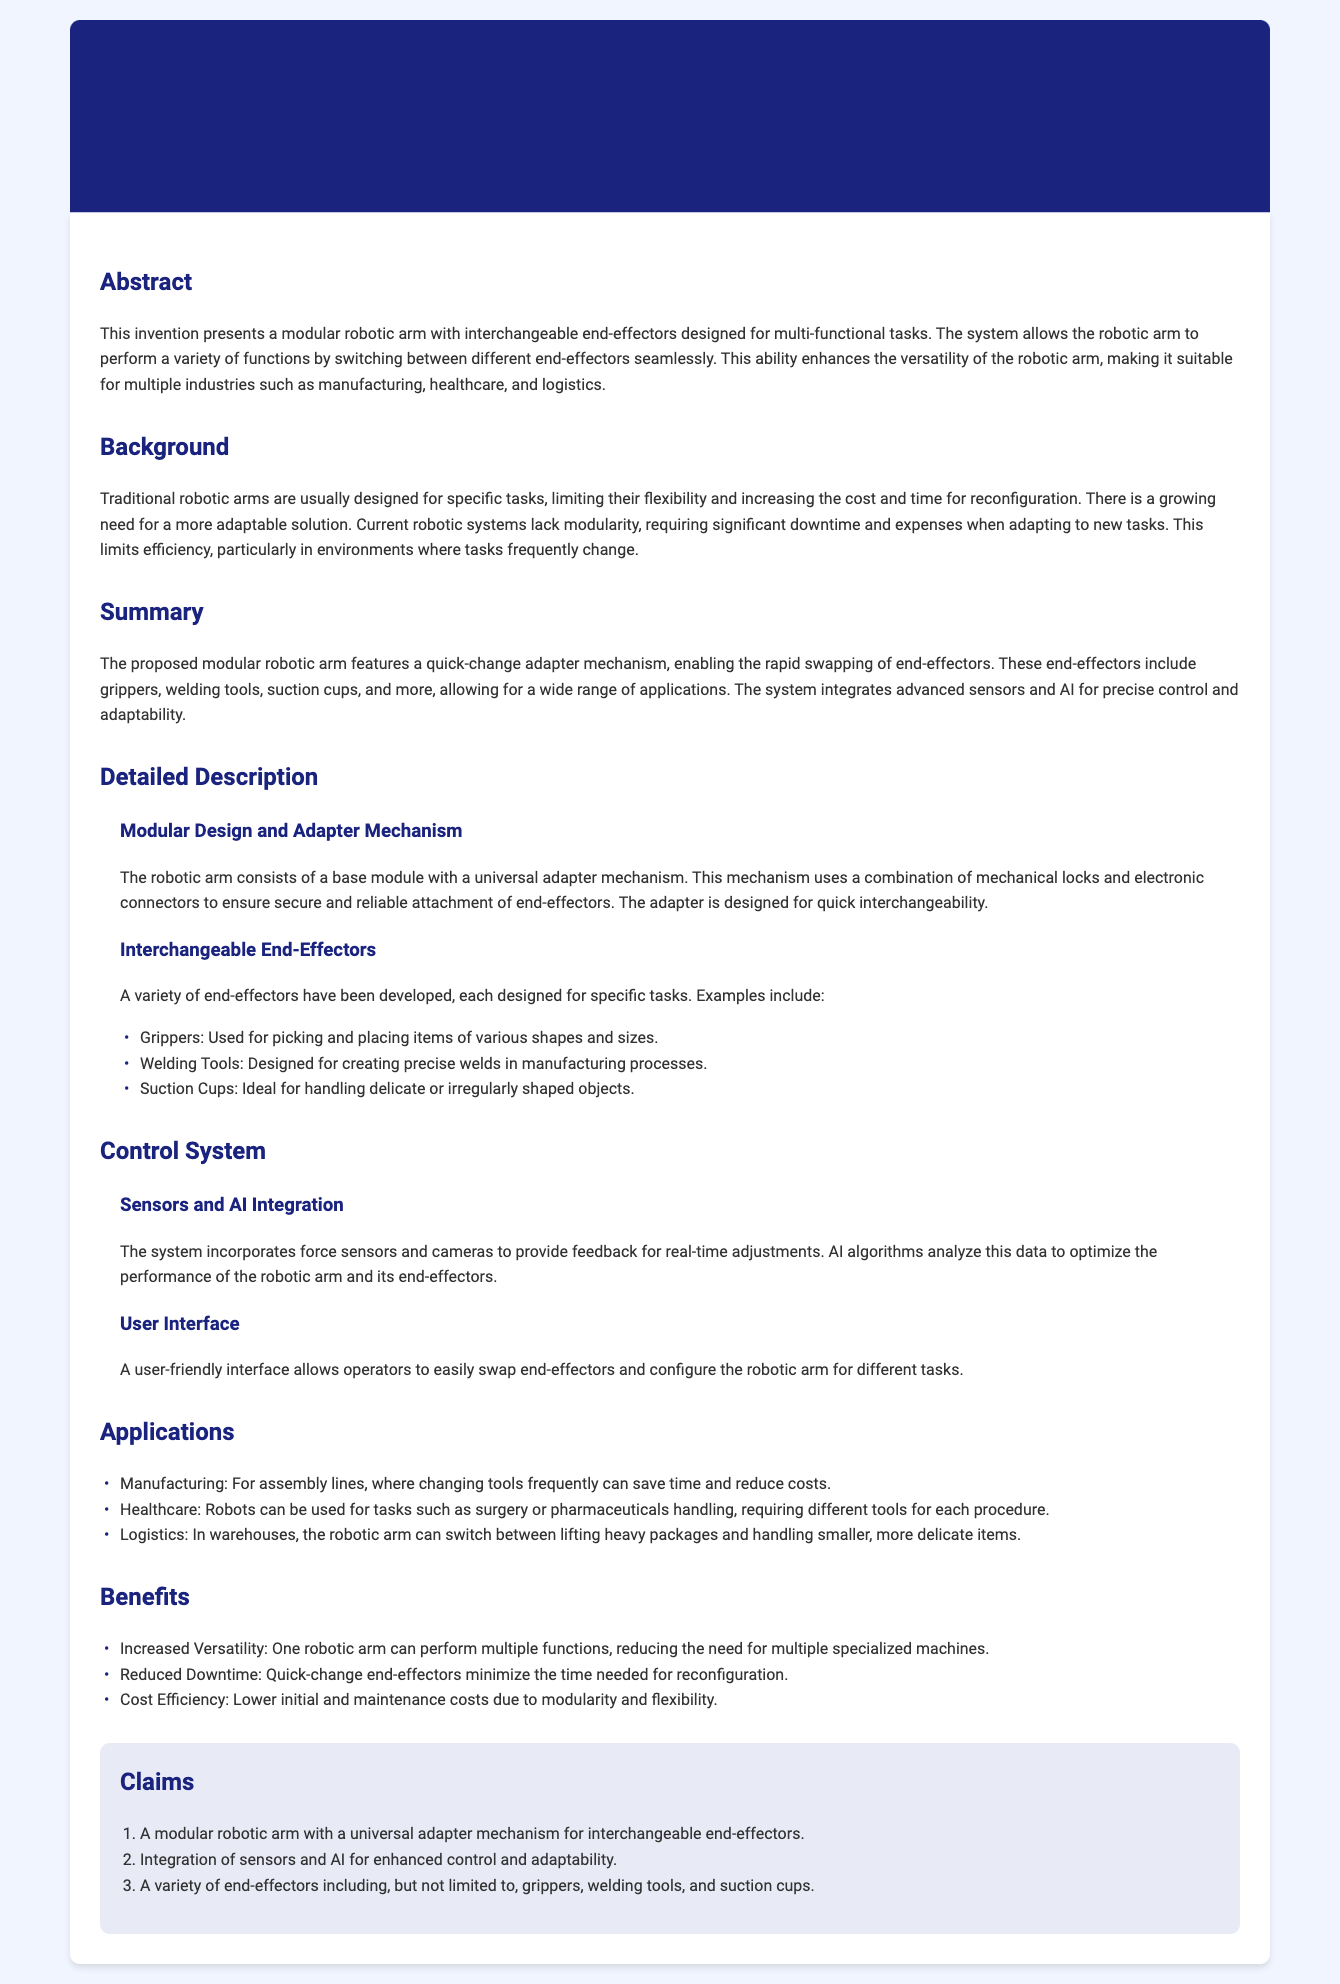What is the title of the patent application? The title of the patent application is stated clearly in the document header.
Answer: Modular Robotic Arm with Interchangeable End-Effectors for Multi-Functional Usage What is the purpose of the modular robotic arm? The purpose of the robotic arm is described in the abstract section which outlines its capabilities.
Answer: For multi-functional tasks What industries can benefit from this technology? The applications section lists multiple industries that can utilize the robotic arm.
Answer: Manufacturing, healthcare, logistics What type of mechanism is used for interchangeable end-effectors? The detailed description section discusses the specific mechanism used in the design.
Answer: Quick-change adapter mechanism What kind of sensors are integrated into the system? The control system section includes information about the sensors used in the robotic arm.
Answer: Force sensors and cameras How many types of end-effectors are mentioned in the document? The section on interchangeable end-effectors lists examples, hence can be counted.
Answer: Three What is one benefit of the modular robotic arm? The benefits section highlights various advantages of using the robotic arm.
Answer: Increased Versatility What is a key feature of the user interface? The control system section describes the user interface and its characteristics.
Answer: User-friendly interface What is one application of the robotic arm in healthcare? The applications section gives examples of tasks the robotic arm can perform in healthcare.
Answer: Surgery 